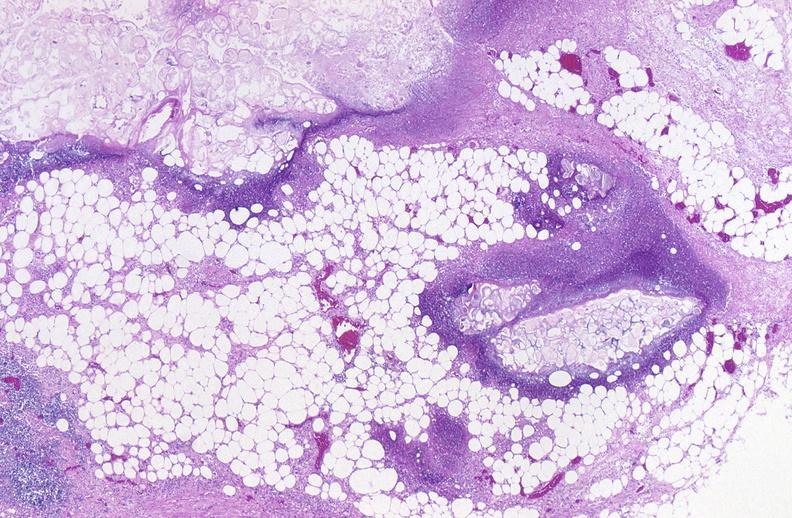what does this image show?
Answer the question using a single word or phrase. Pancreatic fat necrosis 